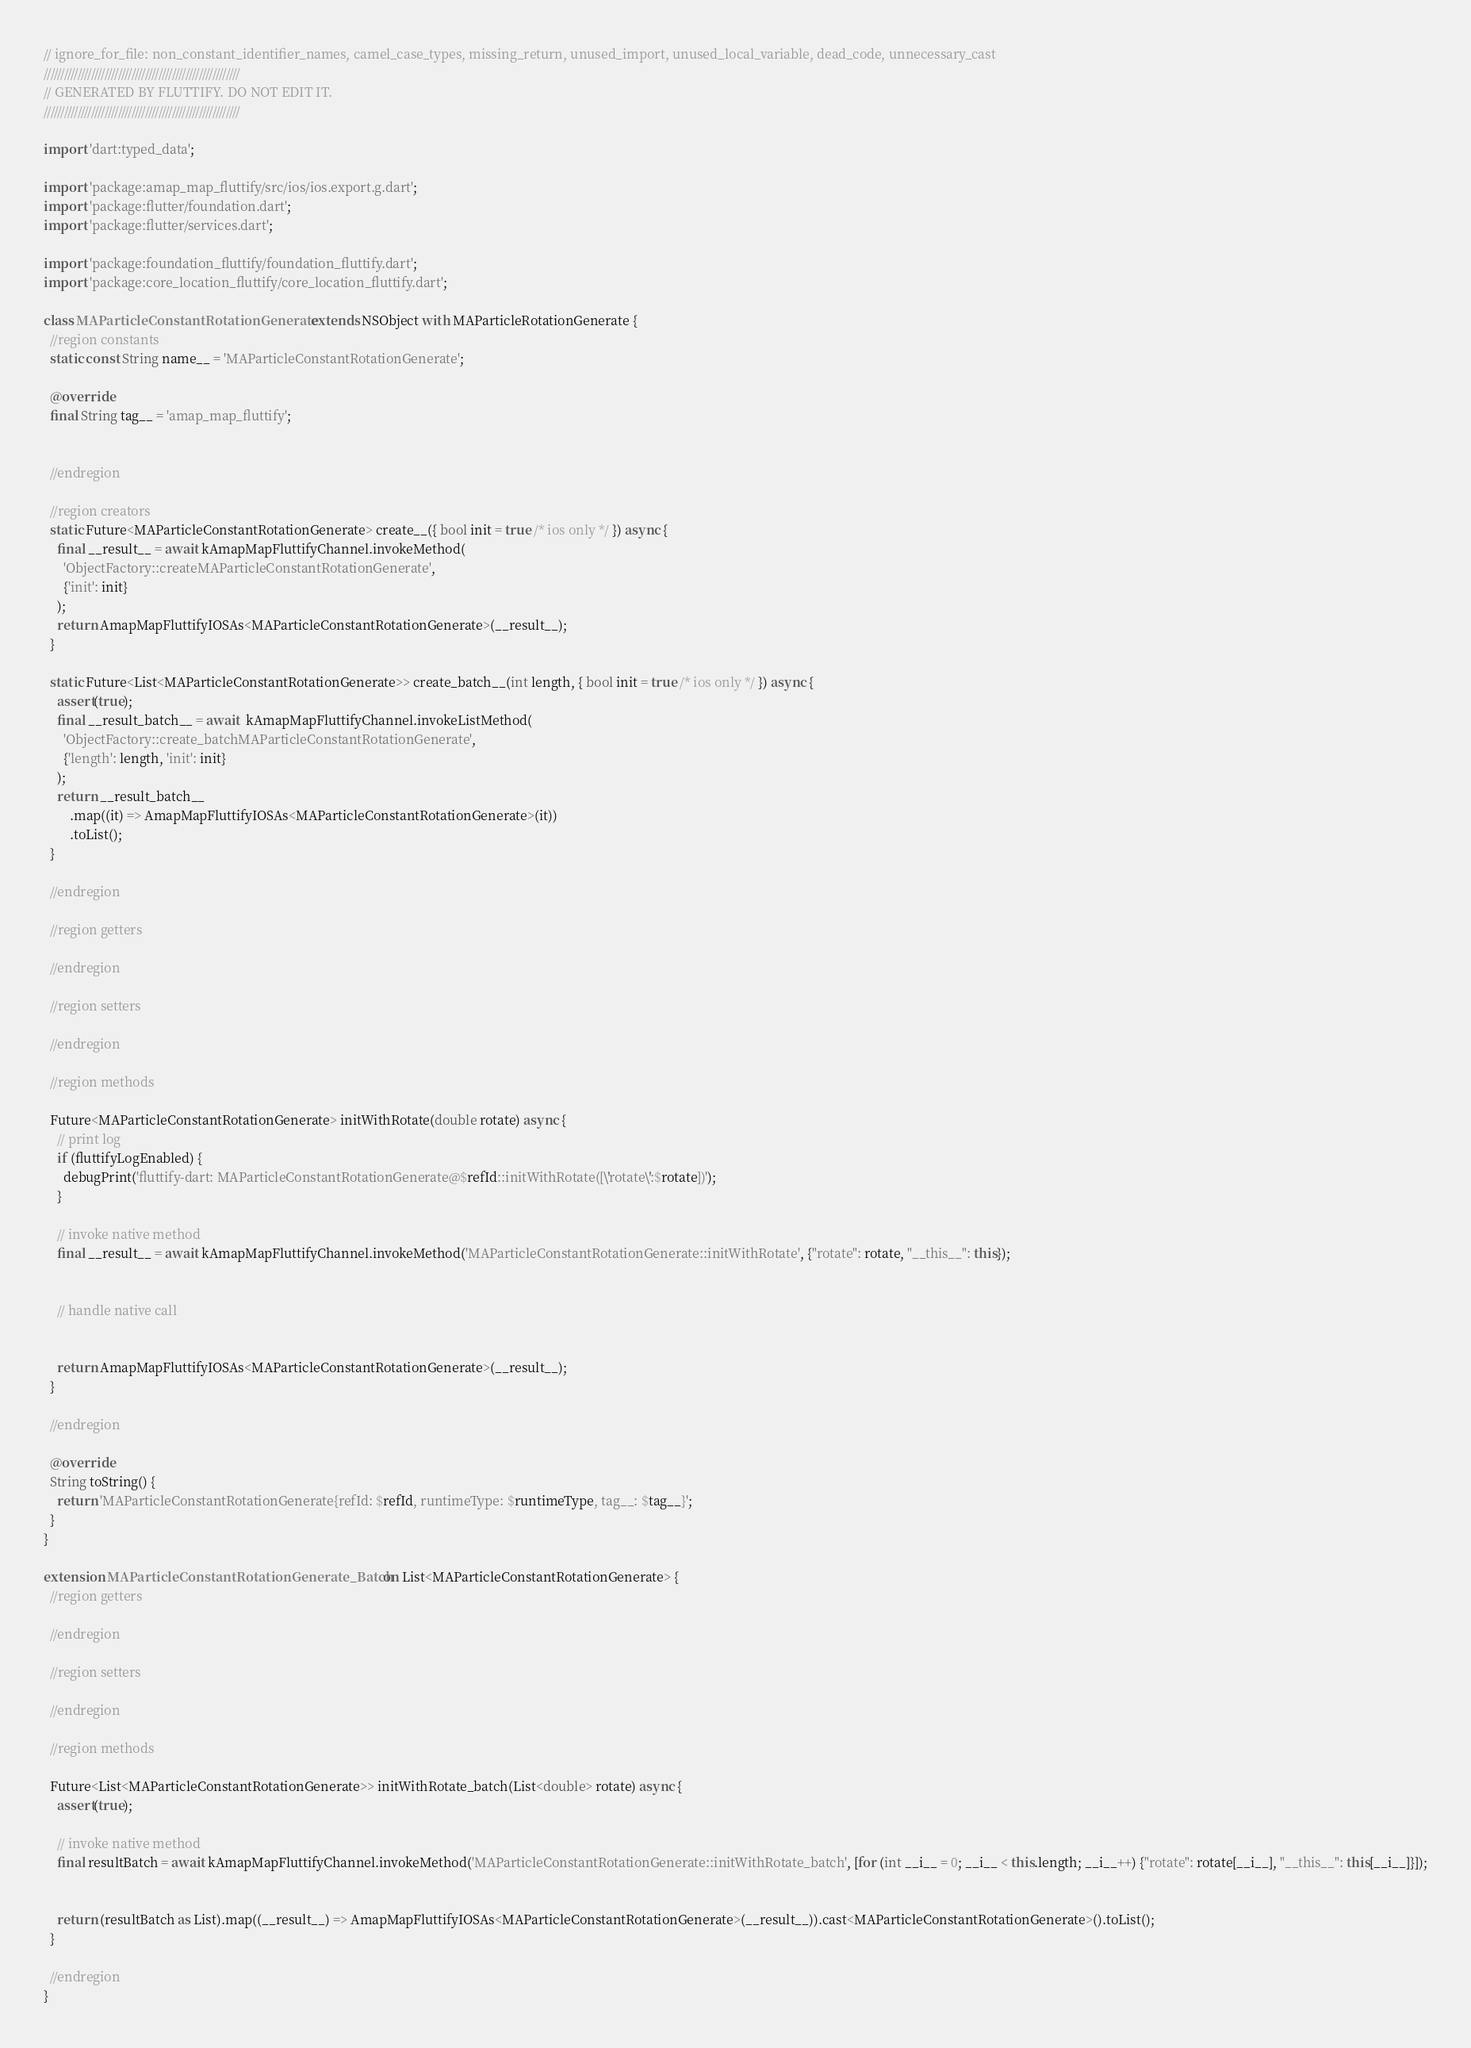Convert code to text. <code><loc_0><loc_0><loc_500><loc_500><_Dart_>// ignore_for_file: non_constant_identifier_names, camel_case_types, missing_return, unused_import, unused_local_variable, dead_code, unnecessary_cast
//////////////////////////////////////////////////////////
// GENERATED BY FLUTTIFY. DO NOT EDIT IT.
//////////////////////////////////////////////////////////

import 'dart:typed_data';

import 'package:amap_map_fluttify/src/ios/ios.export.g.dart';
import 'package:flutter/foundation.dart';
import 'package:flutter/services.dart';

import 'package:foundation_fluttify/foundation_fluttify.dart';
import 'package:core_location_fluttify/core_location_fluttify.dart';

class MAParticleConstantRotationGenerate extends NSObject with MAParticleRotationGenerate {
  //region constants
  static const String name__ = 'MAParticleConstantRotationGenerate';

  @override
  final String tag__ = 'amap_map_fluttify';

  
  //endregion

  //region creators
  static Future<MAParticleConstantRotationGenerate> create__({ bool init = true /* ios only */ }) async {
    final __result__ = await kAmapMapFluttifyChannel.invokeMethod(
      'ObjectFactory::createMAParticleConstantRotationGenerate',
      {'init': init}
    );
    return AmapMapFluttifyIOSAs<MAParticleConstantRotationGenerate>(__result__);
  }
  
  static Future<List<MAParticleConstantRotationGenerate>> create_batch__(int length, { bool init = true /* ios only */ }) async {
    assert(true);
    final __result_batch__ = await  kAmapMapFluttifyChannel.invokeListMethod(
      'ObjectFactory::create_batchMAParticleConstantRotationGenerate',
      {'length': length, 'init': init}
    );
    return __result_batch__
        .map((it) => AmapMapFluttifyIOSAs<MAParticleConstantRotationGenerate>(it))
        .toList();
  }
  
  //endregion

  //region getters
  
  //endregion

  //region setters
  
  //endregion

  //region methods
  
  Future<MAParticleConstantRotationGenerate> initWithRotate(double rotate) async {
    // print log
    if (fluttifyLogEnabled) {
      debugPrint('fluttify-dart: MAParticleConstantRotationGenerate@$refId::initWithRotate([\'rotate\':$rotate])');
    }
  
    // invoke native method
    final __result__ = await kAmapMapFluttifyChannel.invokeMethod('MAParticleConstantRotationGenerate::initWithRotate', {"rotate": rotate, "__this__": this});
  
  
    // handle native call
  
  
    return AmapMapFluttifyIOSAs<MAParticleConstantRotationGenerate>(__result__);
  }
  
  //endregion

  @override
  String toString() {
    return 'MAParticleConstantRotationGenerate{refId: $refId, runtimeType: $runtimeType, tag__: $tag__}';
  }
}

extension MAParticleConstantRotationGenerate_Batch on List<MAParticleConstantRotationGenerate> {
  //region getters
  
  //endregion

  //region setters
  
  //endregion

  //region methods
  
  Future<List<MAParticleConstantRotationGenerate>> initWithRotate_batch(List<double> rotate) async {
    assert(true);
  
    // invoke native method
    final resultBatch = await kAmapMapFluttifyChannel.invokeMethod('MAParticleConstantRotationGenerate::initWithRotate_batch', [for (int __i__ = 0; __i__ < this.length; __i__++) {"rotate": rotate[__i__], "__this__": this[__i__]}]);
  
  
    return (resultBatch as List).map((__result__) => AmapMapFluttifyIOSAs<MAParticleConstantRotationGenerate>(__result__)).cast<MAParticleConstantRotationGenerate>().toList();
  }
  
  //endregion
}</code> 